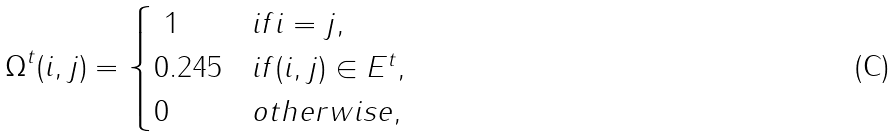<formula> <loc_0><loc_0><loc_500><loc_500>\Omega ^ { t } ( i , j ) = \begin{cases} \ 1 & i f i = j , \\ 0 . 2 4 5 & i f ( i , j ) \in E ^ { t } , \\ 0 & o t h e r w i s e , \end{cases}</formula> 